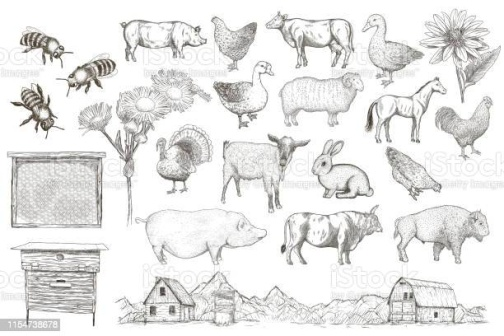Imagine you are one of the animals in the image. Describe a day in your life. As a rabbit in this serene farm, my day starts with the gentle warmth of the morning sun on my fur. Emerging from my burrow, I twitch my nose, testing the air for any signs of predators. Seeing the coast is clear, I hop towards the lush green patch of clover nearby, nibbling at the fresh leaves with delight.

During the day, I roam around the farm, exploring different areas and playing with my fellow rabbits. Occasionally, I encounter the farm's friendly cows and pigs, exchanging curious glances. After a hearty lunch of fresh vegetables provided by the kind farmer, I indulge in a lazy afternoon nap under the shade of the sunflower.

As the evening approaches, I join my companions in watching the beautiful sunset over the mountains, feeling content and grateful for the safety and abundance the farm provides. Finally, I retreat to my cozy burrow, ready to rest and dream of another peaceful day on the farm. Wow, that sounds lovely! How do you interact with the other animals on the farm? Interacting with the various animals on the farm is always an interesting experience. As a rabbit, I'm quite social yet cautious by nature. Early in the morning, the energetic chickens and I often share the sharegpt4v/same patch of land, them pecking at grains while I munch on fresh greens. We keep a respectful distance but exchange occasional glances and friendly nods.

The cows, with their gentle demeanor, often come by the grassy areas where I graze. Sometimes, I find myself hopping around them, feeling a sense of protection while they enjoy their cud. Pigs are fun to watch, especially when they're wallowing in the mud or curiously sniffing the ground. Though I'm quick to dash away when they get too close, their playful nature is quite endearing.

In the evenings, the farm settles into a peaceful calm. The sheep and I might share a moment under the large oak tree, enjoying the cool breeze as the day winds down. The occasional honk from the geese in the distance serves as a reminder of the safety of our farm sanctuary, and I drift off to sleep with a sense of belonging in this diverse animal community. Describe a magical event that happens on this farm after sunset. As the last light of the sun dips behind the mountain range, an enchanting calm descends upon the farm. The usually bustling ground is now serene, a canvas painted in twilight hues. Just as the first stars begin to twinkle, an extraordinary glow emerges from the old barn. It's a soft, ethereal light that seems to call to every creature on the farm.

From every corner, the animals gather, drawn by an inexplicable sense of wonder. The rabbits, like me, hop curiously towards the barns, followed by the cows in a gentle procession, the pigs trotting along with joyous snorts, and the chickens flitting down from their roosts. Even the bees emerge, hovering in a golden halo above the scene.

As we assemble, the old barn doors creak open magically, revealing a breathtaking world of luminescent plants and flowers inside. The once ordinary barn becomes a verdant sanctuary, its walls adorned with vines that sparkle with tiny fairy lights. The animals explore this newfound paradise, discovering ponds that glow a mystical blue and grassy fields that shimmer under the starlight. 

In the center of this magical realm, a grand oak tree, ancient and wise, stands with its branches laden with sparkling fruits. They emit a sweet fragrance that fills the air, inviting everyone to partake. This is a feast like no other, a celestial gift celebrating the unity and harmony of farm life.

As dawn approaches, the glow fades, and we return to our usual selves, carrying the memory of the enchanted night, forever etched in our hearts. The farm awakens to a new day, but we all know that as the sun sets, the magic might return, holding wonders untold and dreams yet to be dreamt. 